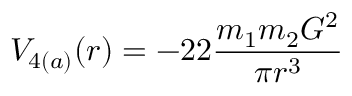Convert formula to latex. <formula><loc_0><loc_0><loc_500><loc_500>V _ { 4 ( a ) } ( r ) = - 2 2 \frac { m _ { 1 } m _ { 2 } G ^ { 2 } } { \pi r ^ { 3 } }</formula> 